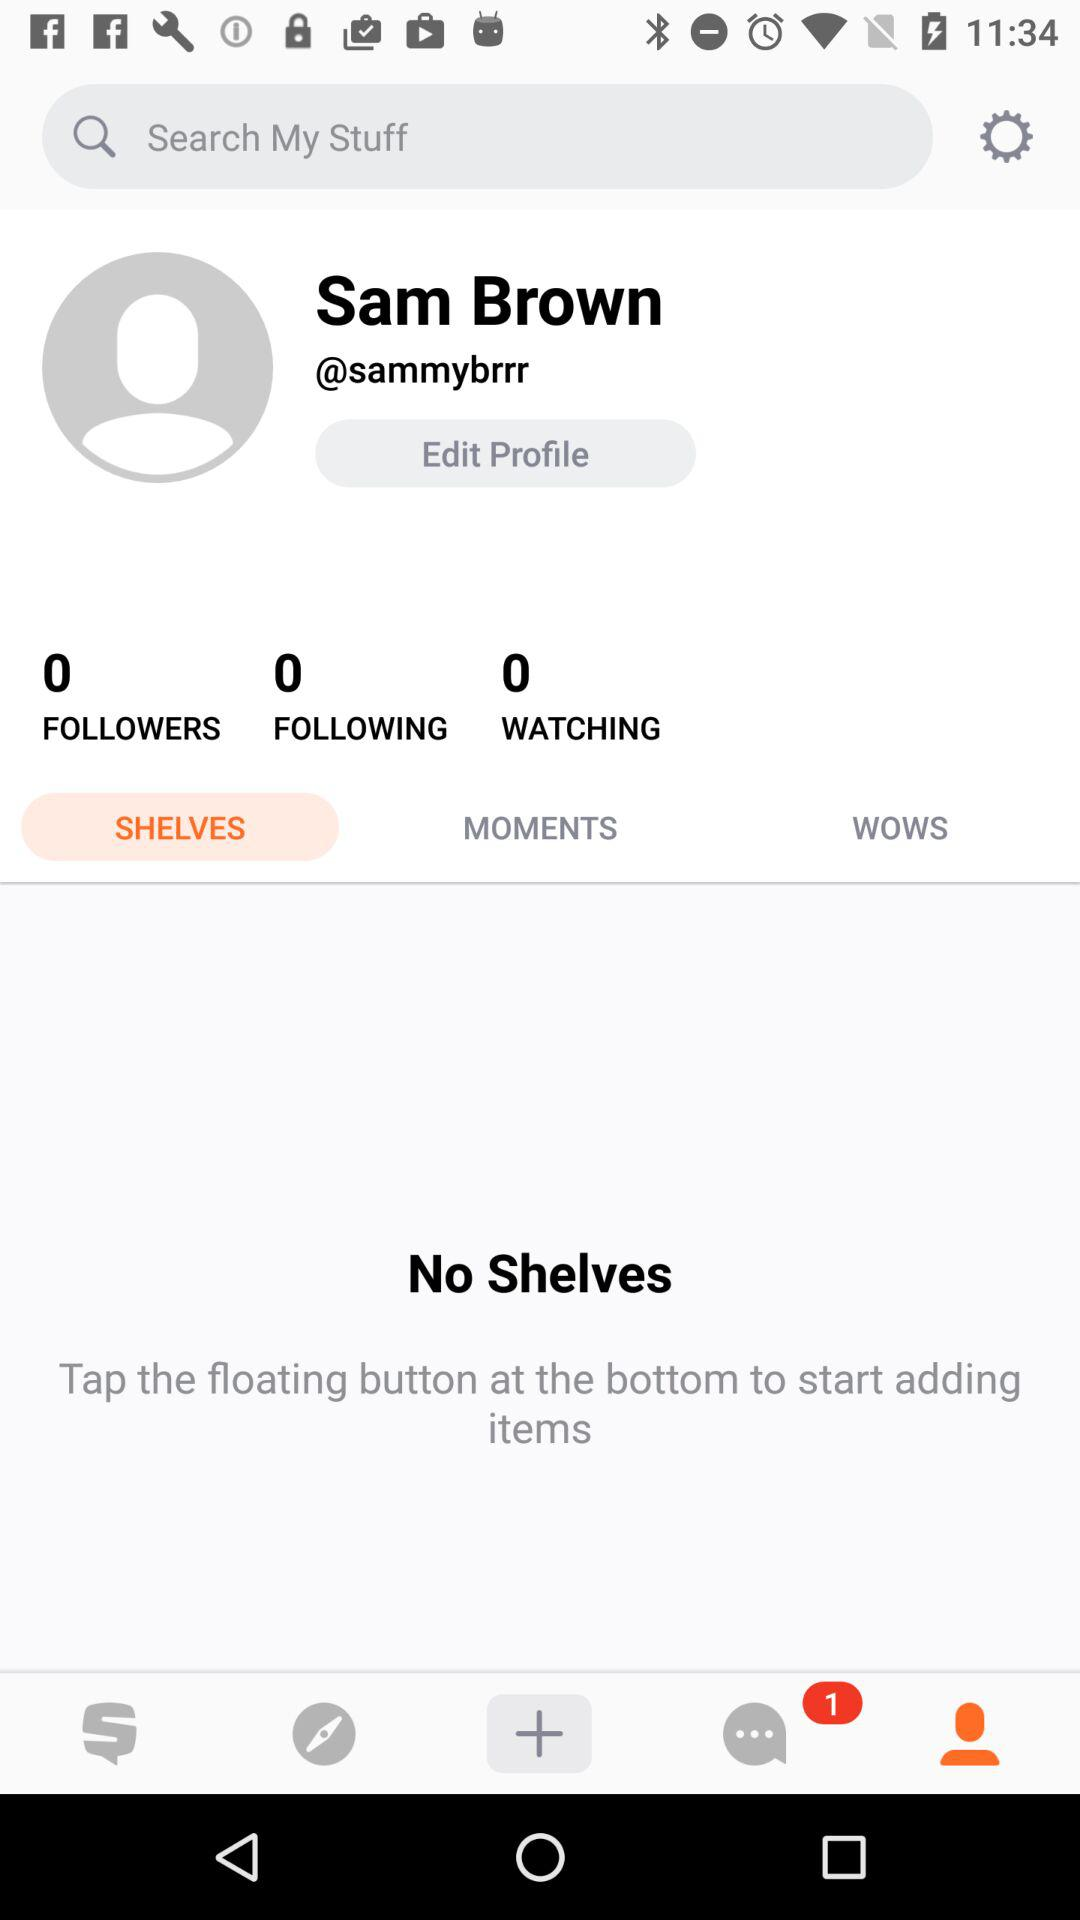What items are added in the moments option?
When the provided information is insufficient, respond with <no answer>. <no answer> 